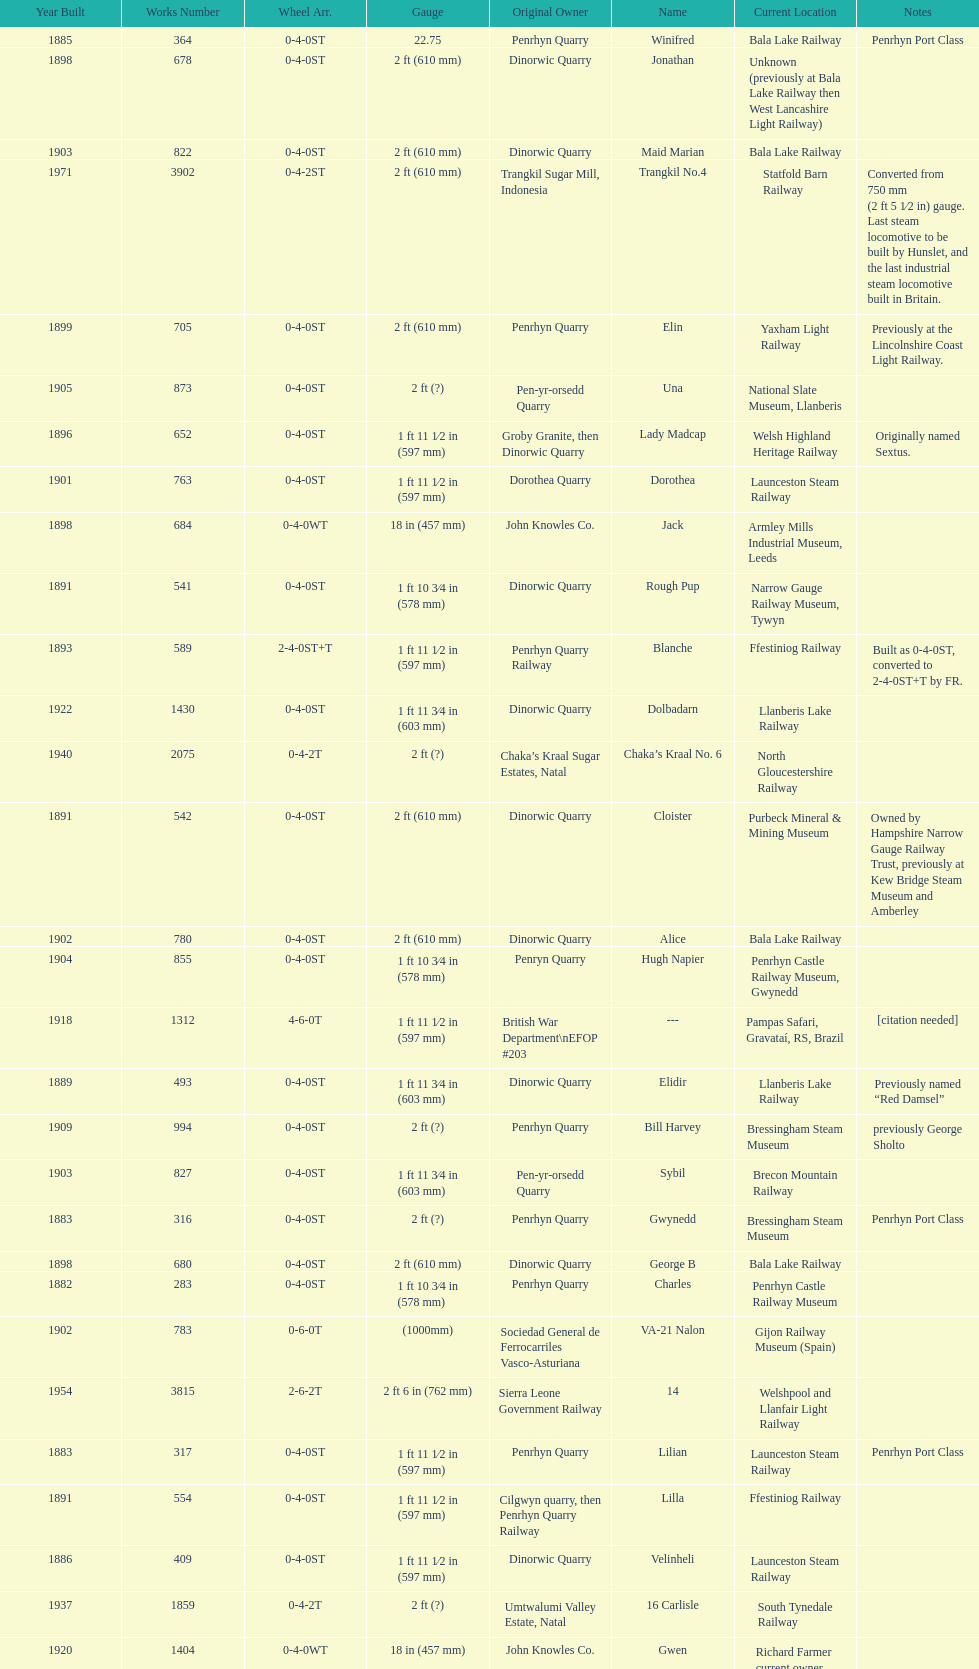Which works number had a larger gauge, 283 or 317? 317. 